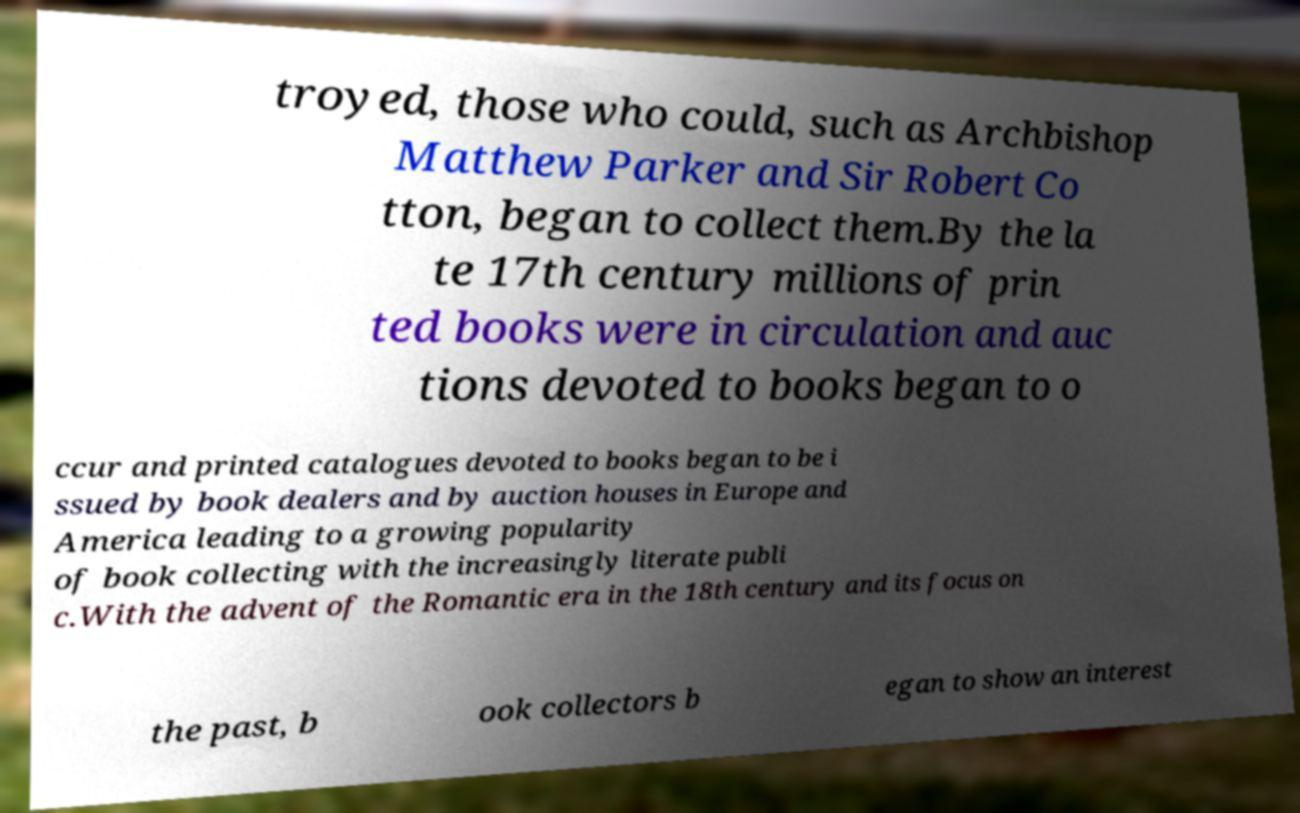Can you read and provide the text displayed in the image?This photo seems to have some interesting text. Can you extract and type it out for me? troyed, those who could, such as Archbishop Matthew Parker and Sir Robert Co tton, began to collect them.By the la te 17th century millions of prin ted books were in circulation and auc tions devoted to books began to o ccur and printed catalogues devoted to books began to be i ssued by book dealers and by auction houses in Europe and America leading to a growing popularity of book collecting with the increasingly literate publi c.With the advent of the Romantic era in the 18th century and its focus on the past, b ook collectors b egan to show an interest 